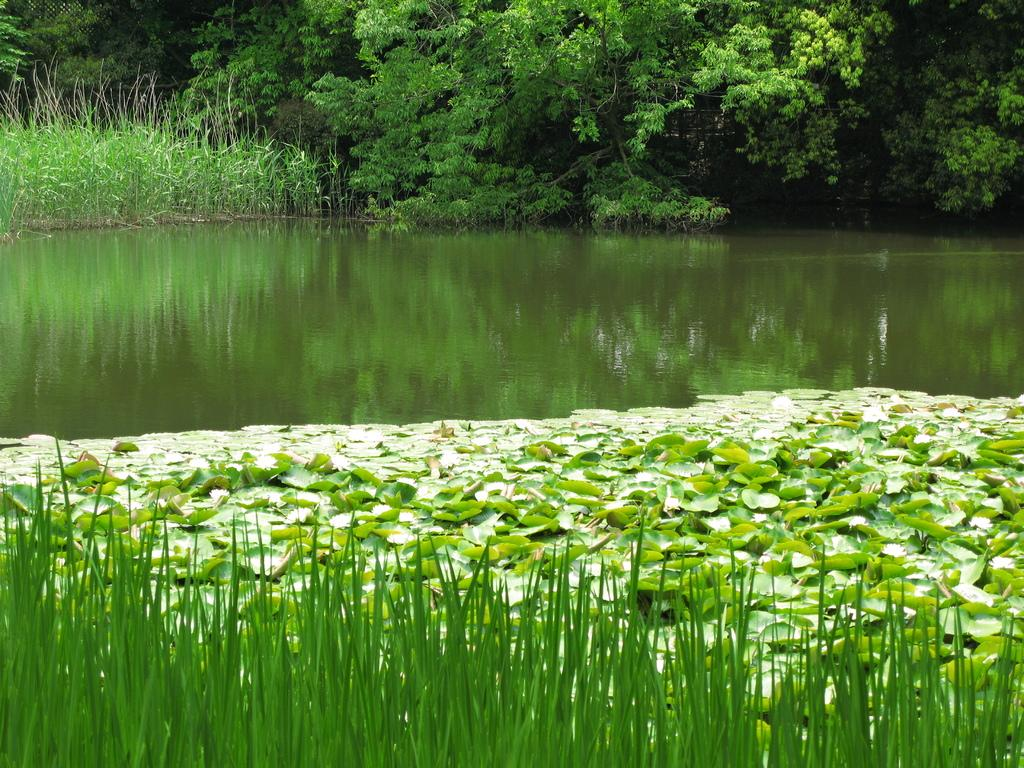What type of vegetation is at the bottom of the image? There is grass at the bottom of the image. What other plant-related objects can be seen in the image? Lotus leaves are present in the image. What can be seen in the distance in the image? There are trees in the background of the image. What is visible behind the trees in the image? There is water visible in the background of the image. What is the governor's opinion on the thought process of the lotus leaves in the image? There is no governor or thought process mentioned in the image; it features grass, lotus leaves, trees, and water. 